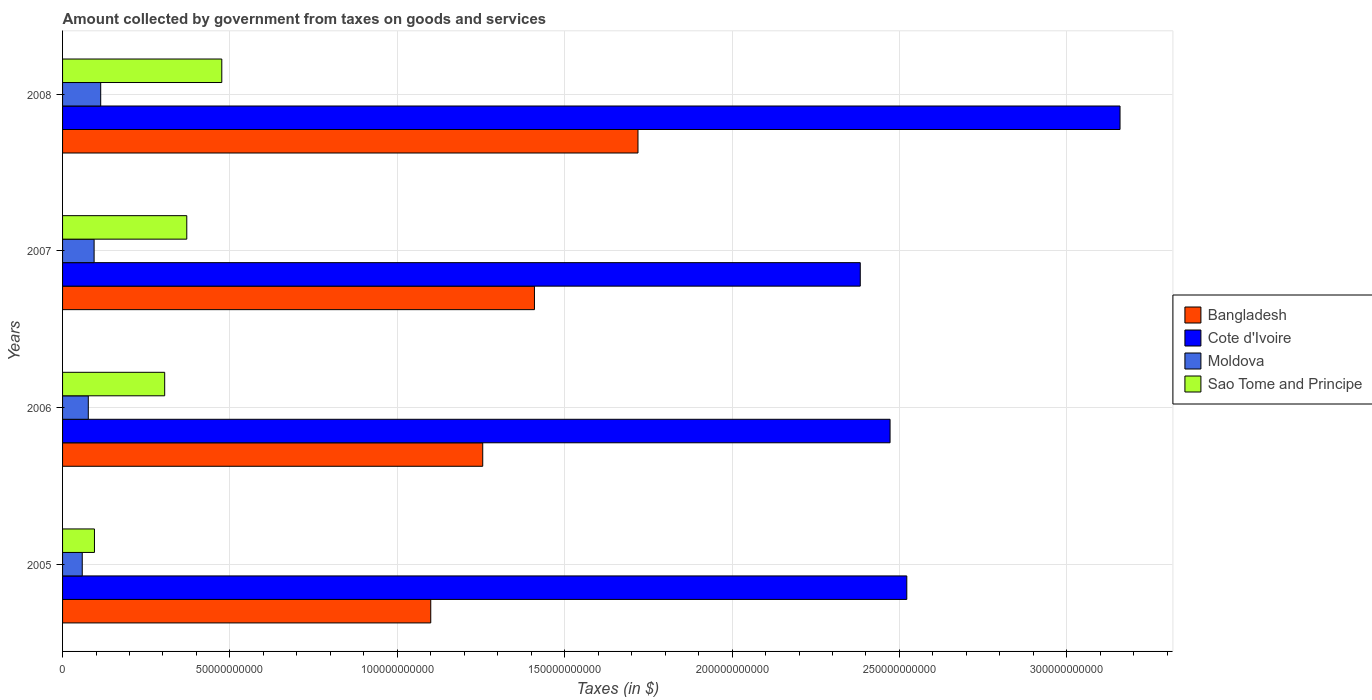How many groups of bars are there?
Offer a very short reply. 4. Are the number of bars per tick equal to the number of legend labels?
Your answer should be very brief. Yes. Are the number of bars on each tick of the Y-axis equal?
Give a very brief answer. Yes. What is the label of the 2nd group of bars from the top?
Keep it short and to the point. 2007. What is the amount collected by government from taxes on goods and services in Cote d'Ivoire in 2007?
Provide a short and direct response. 2.38e+11. Across all years, what is the maximum amount collected by government from taxes on goods and services in Sao Tome and Principe?
Your response must be concise. 4.76e+1. Across all years, what is the minimum amount collected by government from taxes on goods and services in Moldova?
Give a very brief answer. 5.88e+09. What is the total amount collected by government from taxes on goods and services in Cote d'Ivoire in the graph?
Your answer should be compact. 1.05e+12. What is the difference between the amount collected by government from taxes on goods and services in Bangladesh in 2005 and that in 2007?
Provide a short and direct response. -3.10e+1. What is the difference between the amount collected by government from taxes on goods and services in Moldova in 2006 and the amount collected by government from taxes on goods and services in Cote d'Ivoire in 2008?
Keep it short and to the point. -3.08e+11. What is the average amount collected by government from taxes on goods and services in Sao Tome and Principe per year?
Your answer should be very brief. 3.12e+1. In the year 2006, what is the difference between the amount collected by government from taxes on goods and services in Sao Tome and Principe and amount collected by government from taxes on goods and services in Moldova?
Your answer should be very brief. 2.28e+1. In how many years, is the amount collected by government from taxes on goods and services in Bangladesh greater than 270000000000 $?
Your response must be concise. 0. What is the ratio of the amount collected by government from taxes on goods and services in Moldova in 2005 to that in 2008?
Offer a terse response. 0.52. Is the amount collected by government from taxes on goods and services in Sao Tome and Principe in 2005 less than that in 2008?
Offer a very short reply. Yes. What is the difference between the highest and the second highest amount collected by government from taxes on goods and services in Cote d'Ivoire?
Give a very brief answer. 6.37e+1. What is the difference between the highest and the lowest amount collected by government from taxes on goods and services in Cote d'Ivoire?
Ensure brevity in your answer.  7.76e+1. Is the sum of the amount collected by government from taxes on goods and services in Sao Tome and Principe in 2007 and 2008 greater than the maximum amount collected by government from taxes on goods and services in Bangladesh across all years?
Your response must be concise. No. What does the 2nd bar from the top in 2008 represents?
Keep it short and to the point. Moldova. What does the 1st bar from the bottom in 2005 represents?
Your response must be concise. Bangladesh. How many bars are there?
Provide a succinct answer. 16. What is the difference between two consecutive major ticks on the X-axis?
Offer a terse response. 5.00e+1. Are the values on the major ticks of X-axis written in scientific E-notation?
Your response must be concise. No. Does the graph contain grids?
Offer a terse response. Yes. Where does the legend appear in the graph?
Give a very brief answer. Center right. How are the legend labels stacked?
Ensure brevity in your answer.  Vertical. What is the title of the graph?
Provide a short and direct response. Amount collected by government from taxes on goods and services. What is the label or title of the X-axis?
Give a very brief answer. Taxes (in $). What is the label or title of the Y-axis?
Offer a terse response. Years. What is the Taxes (in $) in Bangladesh in 2005?
Give a very brief answer. 1.10e+11. What is the Taxes (in $) in Cote d'Ivoire in 2005?
Offer a terse response. 2.52e+11. What is the Taxes (in $) in Moldova in 2005?
Offer a very short reply. 5.88e+09. What is the Taxes (in $) in Sao Tome and Principe in 2005?
Make the answer very short. 9.52e+09. What is the Taxes (in $) of Bangladesh in 2006?
Your response must be concise. 1.26e+11. What is the Taxes (in $) of Cote d'Ivoire in 2006?
Make the answer very short. 2.47e+11. What is the Taxes (in $) in Moldova in 2006?
Offer a terse response. 7.69e+09. What is the Taxes (in $) in Sao Tome and Principe in 2006?
Make the answer very short. 3.05e+1. What is the Taxes (in $) in Bangladesh in 2007?
Give a very brief answer. 1.41e+11. What is the Taxes (in $) of Cote d'Ivoire in 2007?
Your answer should be compact. 2.38e+11. What is the Taxes (in $) in Moldova in 2007?
Keep it short and to the point. 9.43e+09. What is the Taxes (in $) of Sao Tome and Principe in 2007?
Make the answer very short. 3.71e+1. What is the Taxes (in $) of Bangladesh in 2008?
Your answer should be compact. 1.72e+11. What is the Taxes (in $) in Cote d'Ivoire in 2008?
Your answer should be compact. 3.16e+11. What is the Taxes (in $) in Moldova in 2008?
Ensure brevity in your answer.  1.14e+1. What is the Taxes (in $) of Sao Tome and Principe in 2008?
Provide a short and direct response. 4.76e+1. Across all years, what is the maximum Taxes (in $) of Bangladesh?
Ensure brevity in your answer.  1.72e+11. Across all years, what is the maximum Taxes (in $) of Cote d'Ivoire?
Offer a very short reply. 3.16e+11. Across all years, what is the maximum Taxes (in $) in Moldova?
Offer a terse response. 1.14e+1. Across all years, what is the maximum Taxes (in $) of Sao Tome and Principe?
Offer a very short reply. 4.76e+1. Across all years, what is the minimum Taxes (in $) in Bangladesh?
Your response must be concise. 1.10e+11. Across all years, what is the minimum Taxes (in $) of Cote d'Ivoire?
Provide a short and direct response. 2.38e+11. Across all years, what is the minimum Taxes (in $) in Moldova?
Your answer should be compact. 5.88e+09. Across all years, what is the minimum Taxes (in $) of Sao Tome and Principe?
Keep it short and to the point. 9.52e+09. What is the total Taxes (in $) of Bangladesh in the graph?
Keep it short and to the point. 5.48e+11. What is the total Taxes (in $) of Cote d'Ivoire in the graph?
Your response must be concise. 1.05e+12. What is the total Taxes (in $) in Moldova in the graph?
Your response must be concise. 3.44e+1. What is the total Taxes (in $) of Sao Tome and Principe in the graph?
Offer a very short reply. 1.25e+11. What is the difference between the Taxes (in $) of Bangladesh in 2005 and that in 2006?
Ensure brevity in your answer.  -1.55e+1. What is the difference between the Taxes (in $) of Cote d'Ivoire in 2005 and that in 2006?
Your answer should be very brief. 5.00e+09. What is the difference between the Taxes (in $) of Moldova in 2005 and that in 2006?
Your response must be concise. -1.80e+09. What is the difference between the Taxes (in $) of Sao Tome and Principe in 2005 and that in 2006?
Keep it short and to the point. -2.10e+1. What is the difference between the Taxes (in $) in Bangladesh in 2005 and that in 2007?
Your response must be concise. -3.10e+1. What is the difference between the Taxes (in $) in Cote d'Ivoire in 2005 and that in 2007?
Make the answer very short. 1.39e+1. What is the difference between the Taxes (in $) of Moldova in 2005 and that in 2007?
Your answer should be compact. -3.54e+09. What is the difference between the Taxes (in $) in Sao Tome and Principe in 2005 and that in 2007?
Provide a short and direct response. -2.76e+1. What is the difference between the Taxes (in $) in Bangladesh in 2005 and that in 2008?
Your response must be concise. -6.19e+1. What is the difference between the Taxes (in $) in Cote d'Ivoire in 2005 and that in 2008?
Your answer should be very brief. -6.37e+1. What is the difference between the Taxes (in $) of Moldova in 2005 and that in 2008?
Provide a succinct answer. -5.51e+09. What is the difference between the Taxes (in $) in Sao Tome and Principe in 2005 and that in 2008?
Your response must be concise. -3.80e+1. What is the difference between the Taxes (in $) in Bangladesh in 2006 and that in 2007?
Your answer should be very brief. -1.55e+1. What is the difference between the Taxes (in $) in Cote d'Ivoire in 2006 and that in 2007?
Ensure brevity in your answer.  8.90e+09. What is the difference between the Taxes (in $) in Moldova in 2006 and that in 2007?
Ensure brevity in your answer.  -1.74e+09. What is the difference between the Taxes (in $) of Sao Tome and Principe in 2006 and that in 2007?
Offer a very short reply. -6.60e+09. What is the difference between the Taxes (in $) of Bangladesh in 2006 and that in 2008?
Provide a succinct answer. -4.64e+1. What is the difference between the Taxes (in $) of Cote d'Ivoire in 2006 and that in 2008?
Make the answer very short. -6.87e+1. What is the difference between the Taxes (in $) in Moldova in 2006 and that in 2008?
Ensure brevity in your answer.  -3.71e+09. What is the difference between the Taxes (in $) in Sao Tome and Principe in 2006 and that in 2008?
Your response must be concise. -1.71e+1. What is the difference between the Taxes (in $) of Bangladesh in 2007 and that in 2008?
Give a very brief answer. -3.09e+1. What is the difference between the Taxes (in $) in Cote d'Ivoire in 2007 and that in 2008?
Make the answer very short. -7.76e+1. What is the difference between the Taxes (in $) of Moldova in 2007 and that in 2008?
Provide a succinct answer. -1.97e+09. What is the difference between the Taxes (in $) in Sao Tome and Principe in 2007 and that in 2008?
Provide a short and direct response. -1.05e+1. What is the difference between the Taxes (in $) of Bangladesh in 2005 and the Taxes (in $) of Cote d'Ivoire in 2006?
Ensure brevity in your answer.  -1.37e+11. What is the difference between the Taxes (in $) of Bangladesh in 2005 and the Taxes (in $) of Moldova in 2006?
Keep it short and to the point. 1.02e+11. What is the difference between the Taxes (in $) of Bangladesh in 2005 and the Taxes (in $) of Sao Tome and Principe in 2006?
Offer a terse response. 7.95e+1. What is the difference between the Taxes (in $) of Cote d'Ivoire in 2005 and the Taxes (in $) of Moldova in 2006?
Provide a succinct answer. 2.45e+11. What is the difference between the Taxes (in $) of Cote d'Ivoire in 2005 and the Taxes (in $) of Sao Tome and Principe in 2006?
Ensure brevity in your answer.  2.22e+11. What is the difference between the Taxes (in $) of Moldova in 2005 and the Taxes (in $) of Sao Tome and Principe in 2006?
Ensure brevity in your answer.  -2.46e+1. What is the difference between the Taxes (in $) of Bangladesh in 2005 and the Taxes (in $) of Cote d'Ivoire in 2007?
Make the answer very short. -1.28e+11. What is the difference between the Taxes (in $) of Bangladesh in 2005 and the Taxes (in $) of Moldova in 2007?
Provide a short and direct response. 1.01e+11. What is the difference between the Taxes (in $) of Bangladesh in 2005 and the Taxes (in $) of Sao Tome and Principe in 2007?
Make the answer very short. 7.29e+1. What is the difference between the Taxes (in $) in Cote d'Ivoire in 2005 and the Taxes (in $) in Moldova in 2007?
Ensure brevity in your answer.  2.43e+11. What is the difference between the Taxes (in $) in Cote d'Ivoire in 2005 and the Taxes (in $) in Sao Tome and Principe in 2007?
Provide a succinct answer. 2.15e+11. What is the difference between the Taxes (in $) in Moldova in 2005 and the Taxes (in $) in Sao Tome and Principe in 2007?
Provide a succinct answer. -3.12e+1. What is the difference between the Taxes (in $) of Bangladesh in 2005 and the Taxes (in $) of Cote d'Ivoire in 2008?
Offer a terse response. -2.06e+11. What is the difference between the Taxes (in $) in Bangladesh in 2005 and the Taxes (in $) in Moldova in 2008?
Make the answer very short. 9.86e+1. What is the difference between the Taxes (in $) of Bangladesh in 2005 and the Taxes (in $) of Sao Tome and Principe in 2008?
Keep it short and to the point. 6.24e+1. What is the difference between the Taxes (in $) in Cote d'Ivoire in 2005 and the Taxes (in $) in Moldova in 2008?
Provide a short and direct response. 2.41e+11. What is the difference between the Taxes (in $) in Cote d'Ivoire in 2005 and the Taxes (in $) in Sao Tome and Principe in 2008?
Your answer should be very brief. 2.05e+11. What is the difference between the Taxes (in $) in Moldova in 2005 and the Taxes (in $) in Sao Tome and Principe in 2008?
Provide a short and direct response. -4.17e+1. What is the difference between the Taxes (in $) in Bangladesh in 2006 and the Taxes (in $) in Cote d'Ivoire in 2007?
Provide a short and direct response. -1.13e+11. What is the difference between the Taxes (in $) of Bangladesh in 2006 and the Taxes (in $) of Moldova in 2007?
Provide a succinct answer. 1.16e+11. What is the difference between the Taxes (in $) in Bangladesh in 2006 and the Taxes (in $) in Sao Tome and Principe in 2007?
Ensure brevity in your answer.  8.84e+1. What is the difference between the Taxes (in $) of Cote d'Ivoire in 2006 and the Taxes (in $) of Moldova in 2007?
Keep it short and to the point. 2.38e+11. What is the difference between the Taxes (in $) of Cote d'Ivoire in 2006 and the Taxes (in $) of Sao Tome and Principe in 2007?
Make the answer very short. 2.10e+11. What is the difference between the Taxes (in $) of Moldova in 2006 and the Taxes (in $) of Sao Tome and Principe in 2007?
Make the answer very short. -2.94e+1. What is the difference between the Taxes (in $) in Bangladesh in 2006 and the Taxes (in $) in Cote d'Ivoire in 2008?
Make the answer very short. -1.90e+11. What is the difference between the Taxes (in $) of Bangladesh in 2006 and the Taxes (in $) of Moldova in 2008?
Offer a very short reply. 1.14e+11. What is the difference between the Taxes (in $) in Bangladesh in 2006 and the Taxes (in $) in Sao Tome and Principe in 2008?
Your answer should be compact. 7.79e+1. What is the difference between the Taxes (in $) of Cote d'Ivoire in 2006 and the Taxes (in $) of Moldova in 2008?
Keep it short and to the point. 2.36e+11. What is the difference between the Taxes (in $) in Cote d'Ivoire in 2006 and the Taxes (in $) in Sao Tome and Principe in 2008?
Give a very brief answer. 2.00e+11. What is the difference between the Taxes (in $) of Moldova in 2006 and the Taxes (in $) of Sao Tome and Principe in 2008?
Provide a succinct answer. -3.99e+1. What is the difference between the Taxes (in $) of Bangladesh in 2007 and the Taxes (in $) of Cote d'Ivoire in 2008?
Give a very brief answer. -1.75e+11. What is the difference between the Taxes (in $) in Bangladesh in 2007 and the Taxes (in $) in Moldova in 2008?
Your response must be concise. 1.30e+11. What is the difference between the Taxes (in $) in Bangladesh in 2007 and the Taxes (in $) in Sao Tome and Principe in 2008?
Give a very brief answer. 9.34e+1. What is the difference between the Taxes (in $) in Cote d'Ivoire in 2007 and the Taxes (in $) in Moldova in 2008?
Your answer should be very brief. 2.27e+11. What is the difference between the Taxes (in $) of Cote d'Ivoire in 2007 and the Taxes (in $) of Sao Tome and Principe in 2008?
Give a very brief answer. 1.91e+11. What is the difference between the Taxes (in $) in Moldova in 2007 and the Taxes (in $) in Sao Tome and Principe in 2008?
Ensure brevity in your answer.  -3.81e+1. What is the average Taxes (in $) in Bangladesh per year?
Give a very brief answer. 1.37e+11. What is the average Taxes (in $) of Cote d'Ivoire per year?
Ensure brevity in your answer.  2.63e+11. What is the average Taxes (in $) in Moldova per year?
Keep it short and to the point. 8.60e+09. What is the average Taxes (in $) of Sao Tome and Principe per year?
Your answer should be compact. 3.12e+1. In the year 2005, what is the difference between the Taxes (in $) of Bangladesh and Taxes (in $) of Cote d'Ivoire?
Provide a succinct answer. -1.42e+11. In the year 2005, what is the difference between the Taxes (in $) in Bangladesh and Taxes (in $) in Moldova?
Your answer should be very brief. 1.04e+11. In the year 2005, what is the difference between the Taxes (in $) in Bangladesh and Taxes (in $) in Sao Tome and Principe?
Your response must be concise. 1.00e+11. In the year 2005, what is the difference between the Taxes (in $) in Cote d'Ivoire and Taxes (in $) in Moldova?
Offer a terse response. 2.46e+11. In the year 2005, what is the difference between the Taxes (in $) in Cote d'Ivoire and Taxes (in $) in Sao Tome and Principe?
Offer a very short reply. 2.43e+11. In the year 2005, what is the difference between the Taxes (in $) of Moldova and Taxes (in $) of Sao Tome and Principe?
Give a very brief answer. -3.64e+09. In the year 2006, what is the difference between the Taxes (in $) of Bangladesh and Taxes (in $) of Cote d'Ivoire?
Offer a terse response. -1.22e+11. In the year 2006, what is the difference between the Taxes (in $) in Bangladesh and Taxes (in $) in Moldova?
Make the answer very short. 1.18e+11. In the year 2006, what is the difference between the Taxes (in $) of Bangladesh and Taxes (in $) of Sao Tome and Principe?
Offer a terse response. 9.50e+1. In the year 2006, what is the difference between the Taxes (in $) in Cote d'Ivoire and Taxes (in $) in Moldova?
Offer a terse response. 2.40e+11. In the year 2006, what is the difference between the Taxes (in $) of Cote d'Ivoire and Taxes (in $) of Sao Tome and Principe?
Give a very brief answer. 2.17e+11. In the year 2006, what is the difference between the Taxes (in $) of Moldova and Taxes (in $) of Sao Tome and Principe?
Give a very brief answer. -2.28e+1. In the year 2007, what is the difference between the Taxes (in $) of Bangladesh and Taxes (in $) of Cote d'Ivoire?
Keep it short and to the point. -9.73e+1. In the year 2007, what is the difference between the Taxes (in $) in Bangladesh and Taxes (in $) in Moldova?
Offer a terse response. 1.32e+11. In the year 2007, what is the difference between the Taxes (in $) of Bangladesh and Taxes (in $) of Sao Tome and Principe?
Give a very brief answer. 1.04e+11. In the year 2007, what is the difference between the Taxes (in $) in Cote d'Ivoire and Taxes (in $) in Moldova?
Provide a short and direct response. 2.29e+11. In the year 2007, what is the difference between the Taxes (in $) in Cote d'Ivoire and Taxes (in $) in Sao Tome and Principe?
Keep it short and to the point. 2.01e+11. In the year 2007, what is the difference between the Taxes (in $) of Moldova and Taxes (in $) of Sao Tome and Principe?
Offer a terse response. -2.77e+1. In the year 2008, what is the difference between the Taxes (in $) of Bangladesh and Taxes (in $) of Cote d'Ivoire?
Your response must be concise. -1.44e+11. In the year 2008, what is the difference between the Taxes (in $) in Bangladesh and Taxes (in $) in Moldova?
Ensure brevity in your answer.  1.61e+11. In the year 2008, what is the difference between the Taxes (in $) in Bangladesh and Taxes (in $) in Sao Tome and Principe?
Offer a very short reply. 1.24e+11. In the year 2008, what is the difference between the Taxes (in $) in Cote d'Ivoire and Taxes (in $) in Moldova?
Ensure brevity in your answer.  3.05e+11. In the year 2008, what is the difference between the Taxes (in $) of Cote d'Ivoire and Taxes (in $) of Sao Tome and Principe?
Your answer should be compact. 2.68e+11. In the year 2008, what is the difference between the Taxes (in $) in Moldova and Taxes (in $) in Sao Tome and Principe?
Keep it short and to the point. -3.62e+1. What is the ratio of the Taxes (in $) in Bangladesh in 2005 to that in 2006?
Make the answer very short. 0.88. What is the ratio of the Taxes (in $) of Cote d'Ivoire in 2005 to that in 2006?
Ensure brevity in your answer.  1.02. What is the ratio of the Taxes (in $) in Moldova in 2005 to that in 2006?
Ensure brevity in your answer.  0.77. What is the ratio of the Taxes (in $) in Sao Tome and Principe in 2005 to that in 2006?
Your answer should be very brief. 0.31. What is the ratio of the Taxes (in $) in Bangladesh in 2005 to that in 2007?
Offer a very short reply. 0.78. What is the ratio of the Taxes (in $) of Cote d'Ivoire in 2005 to that in 2007?
Keep it short and to the point. 1.06. What is the ratio of the Taxes (in $) in Moldova in 2005 to that in 2007?
Keep it short and to the point. 0.62. What is the ratio of the Taxes (in $) of Sao Tome and Principe in 2005 to that in 2007?
Make the answer very short. 0.26. What is the ratio of the Taxes (in $) of Bangladesh in 2005 to that in 2008?
Offer a very short reply. 0.64. What is the ratio of the Taxes (in $) in Cote d'Ivoire in 2005 to that in 2008?
Offer a terse response. 0.8. What is the ratio of the Taxes (in $) of Moldova in 2005 to that in 2008?
Ensure brevity in your answer.  0.52. What is the ratio of the Taxes (in $) of Sao Tome and Principe in 2005 to that in 2008?
Your response must be concise. 0.2. What is the ratio of the Taxes (in $) in Bangladesh in 2006 to that in 2007?
Ensure brevity in your answer.  0.89. What is the ratio of the Taxes (in $) in Cote d'Ivoire in 2006 to that in 2007?
Provide a short and direct response. 1.04. What is the ratio of the Taxes (in $) in Moldova in 2006 to that in 2007?
Provide a short and direct response. 0.82. What is the ratio of the Taxes (in $) of Sao Tome and Principe in 2006 to that in 2007?
Your answer should be compact. 0.82. What is the ratio of the Taxes (in $) of Bangladesh in 2006 to that in 2008?
Keep it short and to the point. 0.73. What is the ratio of the Taxes (in $) in Cote d'Ivoire in 2006 to that in 2008?
Offer a terse response. 0.78. What is the ratio of the Taxes (in $) in Moldova in 2006 to that in 2008?
Provide a short and direct response. 0.67. What is the ratio of the Taxes (in $) in Sao Tome and Principe in 2006 to that in 2008?
Offer a terse response. 0.64. What is the ratio of the Taxes (in $) of Bangladesh in 2007 to that in 2008?
Provide a short and direct response. 0.82. What is the ratio of the Taxes (in $) of Cote d'Ivoire in 2007 to that in 2008?
Provide a succinct answer. 0.75. What is the ratio of the Taxes (in $) of Moldova in 2007 to that in 2008?
Provide a short and direct response. 0.83. What is the ratio of the Taxes (in $) in Sao Tome and Principe in 2007 to that in 2008?
Make the answer very short. 0.78. What is the difference between the highest and the second highest Taxes (in $) of Bangladesh?
Give a very brief answer. 3.09e+1. What is the difference between the highest and the second highest Taxes (in $) in Cote d'Ivoire?
Give a very brief answer. 6.37e+1. What is the difference between the highest and the second highest Taxes (in $) in Moldova?
Your answer should be compact. 1.97e+09. What is the difference between the highest and the second highest Taxes (in $) in Sao Tome and Principe?
Your answer should be very brief. 1.05e+1. What is the difference between the highest and the lowest Taxes (in $) of Bangladesh?
Make the answer very short. 6.19e+1. What is the difference between the highest and the lowest Taxes (in $) in Cote d'Ivoire?
Keep it short and to the point. 7.76e+1. What is the difference between the highest and the lowest Taxes (in $) in Moldova?
Give a very brief answer. 5.51e+09. What is the difference between the highest and the lowest Taxes (in $) of Sao Tome and Principe?
Your answer should be compact. 3.80e+1. 